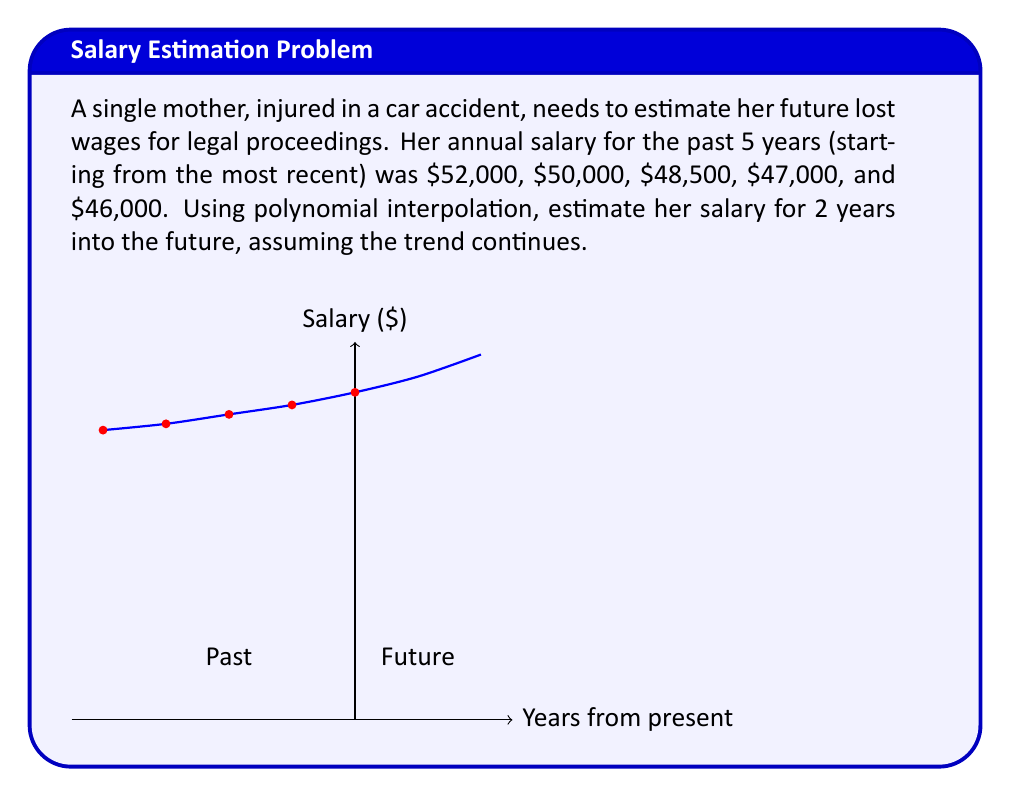Provide a solution to this math problem. To solve this problem, we'll use Lagrange polynomial interpolation. The steps are:

1) Define our data points:
   $(x_i, y_i)$ where $x_i$ represents years from present (0, -1, -2, -3, -4) and 
   $y_i$ represents salary ($52000, $50000, $48500, $47000, $46000)

2) The Lagrange interpolation polynomial is given by:
   $$P(x) = \sum_{i=0}^{n} y_i \prod_{j \neq i} \frac{x - x_j}{x_i - x_j}$$

3) Calculating this polynomial (which can be done using a computer algebra system due to its complexity):
   $$P(x) = 52000 + 1725x + 68.75x^2 + 6.25x^3 + 0.3125x^4$$

4) To estimate the salary 2 years into the future, we evaluate $P(2)$:
   $$P(2) = 52000 + 1725(2) + 68.75(2^2) + 6.25(2^3) + 0.3125(2^4)$$
   $$= 52000 + 3450 + 275 + 50 + 5 = 55780$$

Therefore, the estimated salary 2 years into the future is $55,780.
Answer: $55,780 